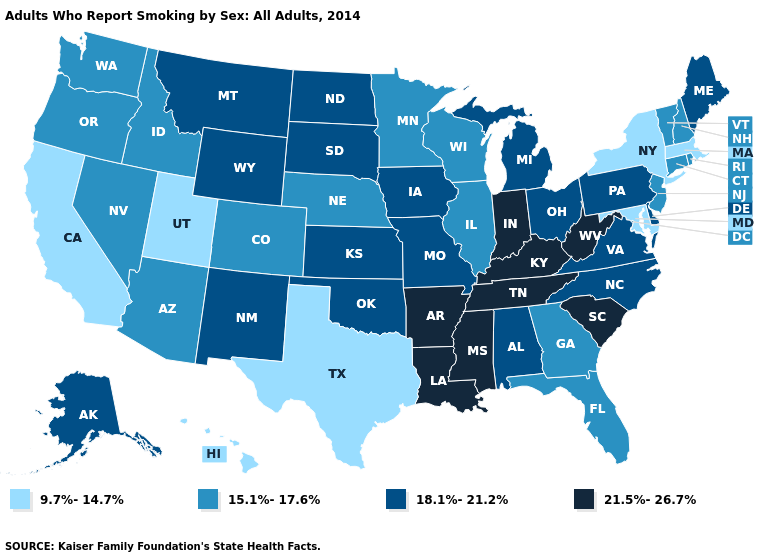Does Kentucky have the highest value in the South?
Write a very short answer. Yes. Does Tennessee have the lowest value in the USA?
Answer briefly. No. Among the states that border California , which have the lowest value?
Be succinct. Arizona, Nevada, Oregon. How many symbols are there in the legend?
Answer briefly. 4. Does Texas have the lowest value in the USA?
Concise answer only. Yes. Name the states that have a value in the range 18.1%-21.2%?
Be succinct. Alabama, Alaska, Delaware, Iowa, Kansas, Maine, Michigan, Missouri, Montana, New Mexico, North Carolina, North Dakota, Ohio, Oklahoma, Pennsylvania, South Dakota, Virginia, Wyoming. Which states have the lowest value in the MidWest?
Write a very short answer. Illinois, Minnesota, Nebraska, Wisconsin. Name the states that have a value in the range 18.1%-21.2%?
Answer briefly. Alabama, Alaska, Delaware, Iowa, Kansas, Maine, Michigan, Missouri, Montana, New Mexico, North Carolina, North Dakota, Ohio, Oklahoma, Pennsylvania, South Dakota, Virginia, Wyoming. Does the map have missing data?
Keep it brief. No. Does Washington have the lowest value in the West?
Write a very short answer. No. What is the value of West Virginia?
Be succinct. 21.5%-26.7%. Which states have the highest value in the USA?
Be succinct. Arkansas, Indiana, Kentucky, Louisiana, Mississippi, South Carolina, Tennessee, West Virginia. What is the value of Wyoming?
Answer briefly. 18.1%-21.2%. Does Indiana have the highest value in the MidWest?
Quick response, please. Yes. Name the states that have a value in the range 9.7%-14.7%?
Be succinct. California, Hawaii, Maryland, Massachusetts, New York, Texas, Utah. 